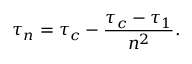Convert formula to latex. <formula><loc_0><loc_0><loc_500><loc_500>\tau _ { n } = \tau _ { c } - \frac { \tau _ { c } - \tau _ { 1 } } { n ^ { 2 } } .</formula> 